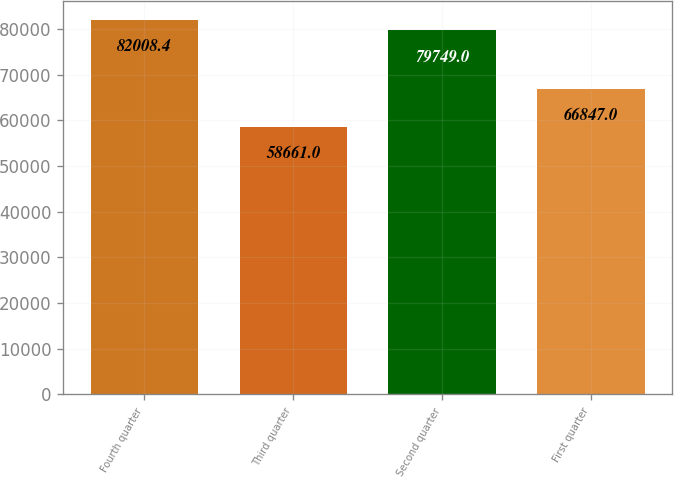Convert chart. <chart><loc_0><loc_0><loc_500><loc_500><bar_chart><fcel>Fourth quarter<fcel>Third quarter<fcel>Second quarter<fcel>First quarter<nl><fcel>82008.4<fcel>58661<fcel>79749<fcel>66847<nl></chart> 